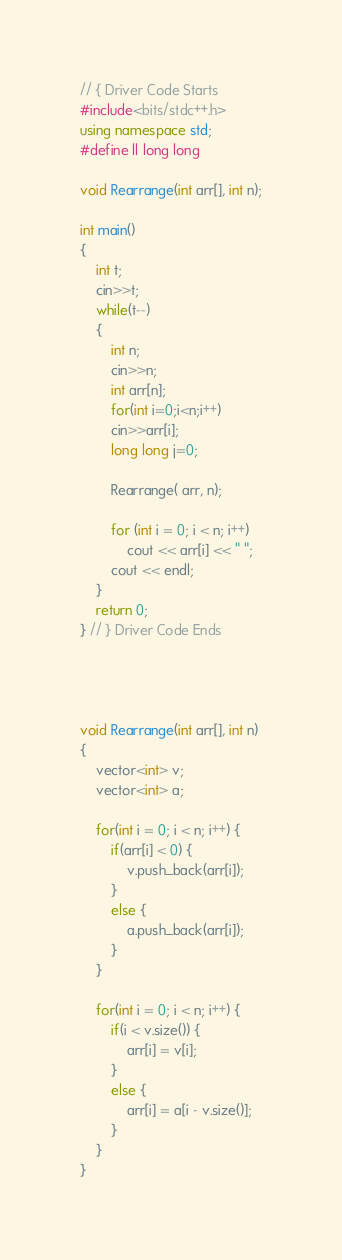Convert code to text. <code><loc_0><loc_0><loc_500><loc_500><_C++_>// { Driver Code Starts
#include<bits/stdc++.h>
using namespace std;
#define ll long long

void Rearrange(int arr[], int n);

int main() 
{ 
    int t;
    cin>>t;
    while(t--)
    {
        int n;
        cin>>n;
        int arr[n];
        for(int i=0;i<n;i++)
        cin>>arr[i];
        long long j=0;
      
        Rearrange( arr, n);
      
        for (int i = 0; i < n; i++) 
            cout << arr[i] << " "; 
        cout << endl;  
    }
    return 0; 
} // } Driver Code Ends




void Rearrange(int arr[], int n)
{
    vector<int> v;
    vector<int> a;
    
    for(int i = 0; i < n; i++) {
        if(arr[i] < 0) {
            v.push_back(arr[i]);
        }
        else {
            a.push_back(arr[i]);
        }
    }
    
    for(int i = 0; i < n; i++) {
        if(i < v.size()) {
            arr[i] = v[i];
        }
        else {
            arr[i] = a[i - v.size()];
        }
    }
}
</code> 